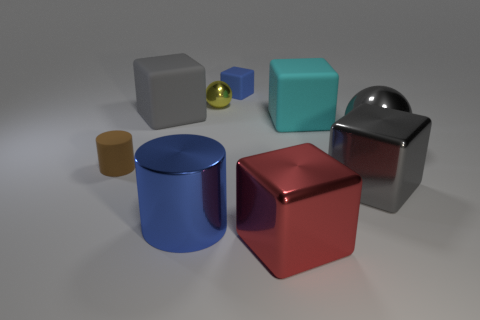Is the material of the big red thing the same as the big blue cylinder?
Offer a terse response. Yes. What size is the object that is the same color as the big cylinder?
Ensure brevity in your answer.  Small. Are there any cubes of the same color as the small metallic ball?
Keep it short and to the point. No. What size is the blue object that is the same material as the big red block?
Provide a short and direct response. Large. What shape is the metal thing that is in front of the shiny object on the left side of the metal ball behind the cyan matte block?
Your response must be concise. Cube. What is the size of the other thing that is the same shape as the big blue object?
Make the answer very short. Small. What size is the gray thing that is to the right of the tiny blue matte cube and on the left side of the big sphere?
Offer a terse response. Large. There is a small matte object that is the same color as the large cylinder; what shape is it?
Your response must be concise. Cube. What is the color of the small cylinder?
Give a very brief answer. Brown. There is a gray object that is left of the large red object; what size is it?
Give a very brief answer. Large. 